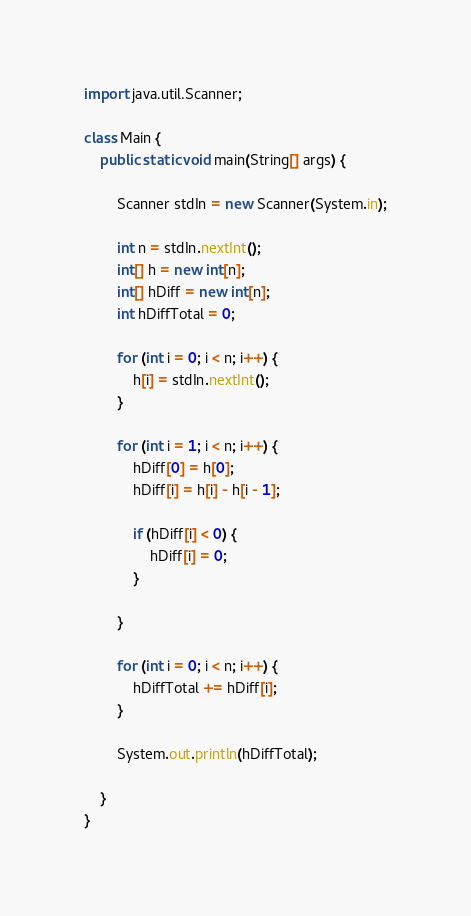Convert code to text. <code><loc_0><loc_0><loc_500><loc_500><_Java_>import java.util.Scanner;

class Main {
	public static void main(String[] args) {
	
		Scanner stdIn = new Scanner(System.in);
		
		int n = stdIn.nextInt();
		int[] h = new int[n];
		int[] hDiff = new int[n];
		int hDiffTotal = 0;
		
		for (int i = 0; i < n; i++) {
			h[i] = stdIn.nextInt();
		}
		
		for (int i = 1; i < n; i++) {
			hDiff[0] = h[0];
			hDiff[i] = h[i] - h[i - 1];
			
			if (hDiff[i] < 0) {
				hDiff[i] = 0;
			}
			
		}
		
		for (int i = 0; i < n; i++) {
			hDiffTotal += hDiff[i];
		}
		
		System.out.println(hDiffTotal);
	
	}
}</code> 